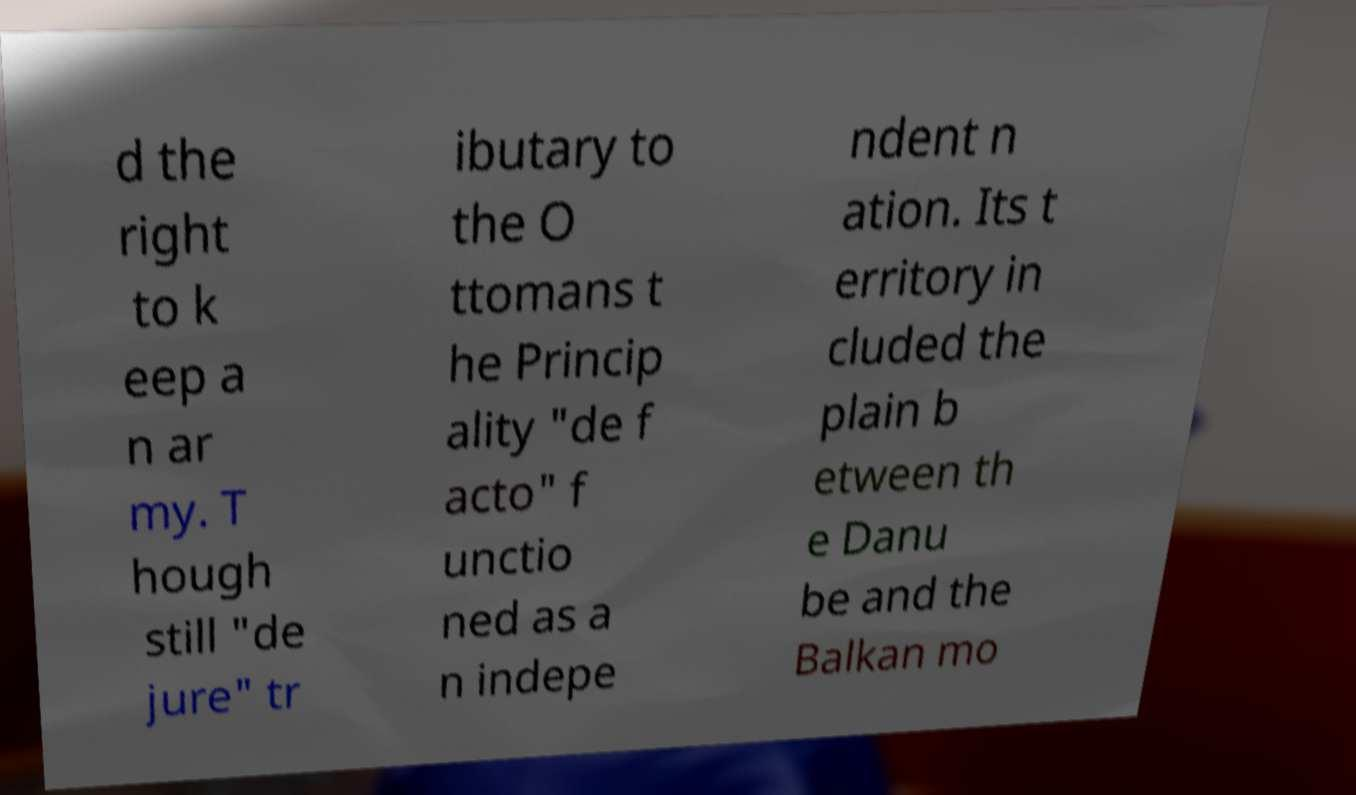For documentation purposes, I need the text within this image transcribed. Could you provide that? d the right to k eep a n ar my. T hough still "de jure" tr ibutary to the O ttomans t he Princip ality "de f acto" f unctio ned as a n indepe ndent n ation. Its t erritory in cluded the plain b etween th e Danu be and the Balkan mo 